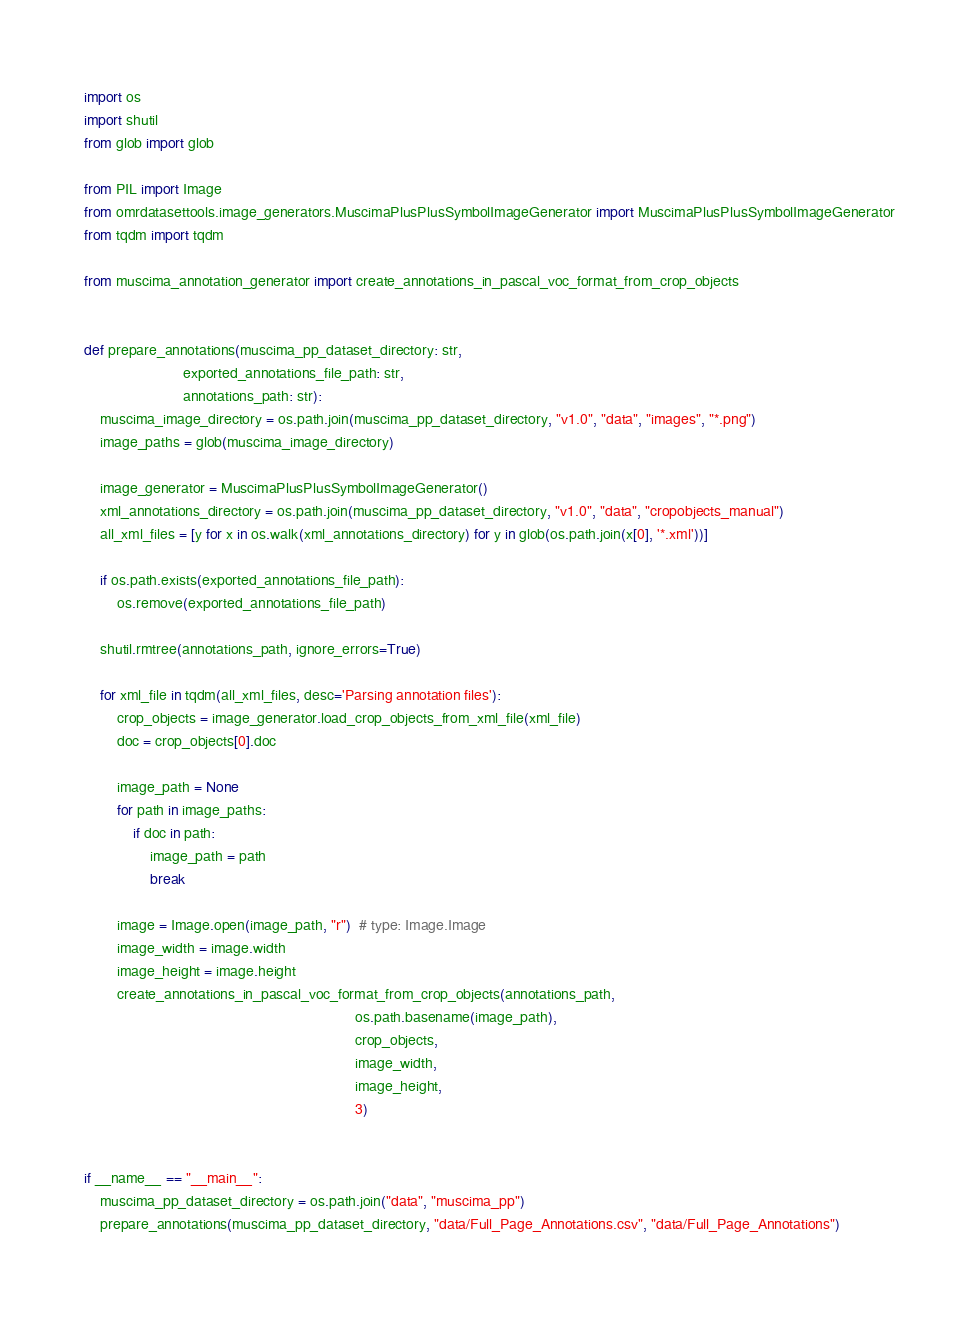<code> <loc_0><loc_0><loc_500><loc_500><_Python_>import os
import shutil
from glob import glob

from PIL import Image
from omrdatasettools.image_generators.MuscimaPlusPlusSymbolImageGenerator import MuscimaPlusPlusSymbolImageGenerator
from tqdm import tqdm

from muscima_annotation_generator import create_annotations_in_pascal_voc_format_from_crop_objects


def prepare_annotations(muscima_pp_dataset_directory: str,
                        exported_annotations_file_path: str,
                        annotations_path: str):
    muscima_image_directory = os.path.join(muscima_pp_dataset_directory, "v1.0", "data", "images", "*.png")
    image_paths = glob(muscima_image_directory)

    image_generator = MuscimaPlusPlusSymbolImageGenerator()
    xml_annotations_directory = os.path.join(muscima_pp_dataset_directory, "v1.0", "data", "cropobjects_manual")
    all_xml_files = [y for x in os.walk(xml_annotations_directory) for y in glob(os.path.join(x[0], '*.xml'))]

    if os.path.exists(exported_annotations_file_path):
        os.remove(exported_annotations_file_path)

    shutil.rmtree(annotations_path, ignore_errors=True)

    for xml_file in tqdm(all_xml_files, desc='Parsing annotation files'):
        crop_objects = image_generator.load_crop_objects_from_xml_file(xml_file)
        doc = crop_objects[0].doc

        image_path = None
        for path in image_paths:
            if doc in path:
                image_path = path
                break

        image = Image.open(image_path, "r")  # type: Image.Image
        image_width = image.width
        image_height = image.height
        create_annotations_in_pascal_voc_format_from_crop_objects(annotations_path,
                                                                  os.path.basename(image_path),
                                                                  crop_objects,
                                                                  image_width,
                                                                  image_height,
                                                                  3)


if __name__ == "__main__":
    muscima_pp_dataset_directory = os.path.join("data", "muscima_pp")
    prepare_annotations(muscima_pp_dataset_directory, "data/Full_Page_Annotations.csv", "data/Full_Page_Annotations")
</code> 